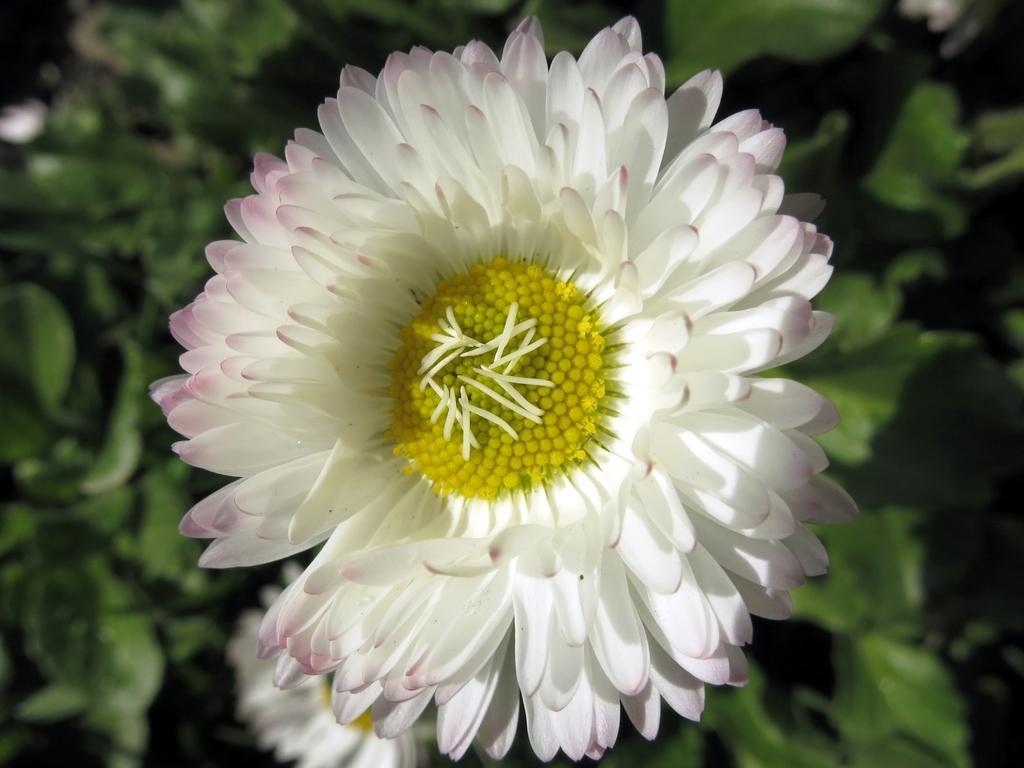Can you describe this image briefly? We can see flowers. In the background it is green. 